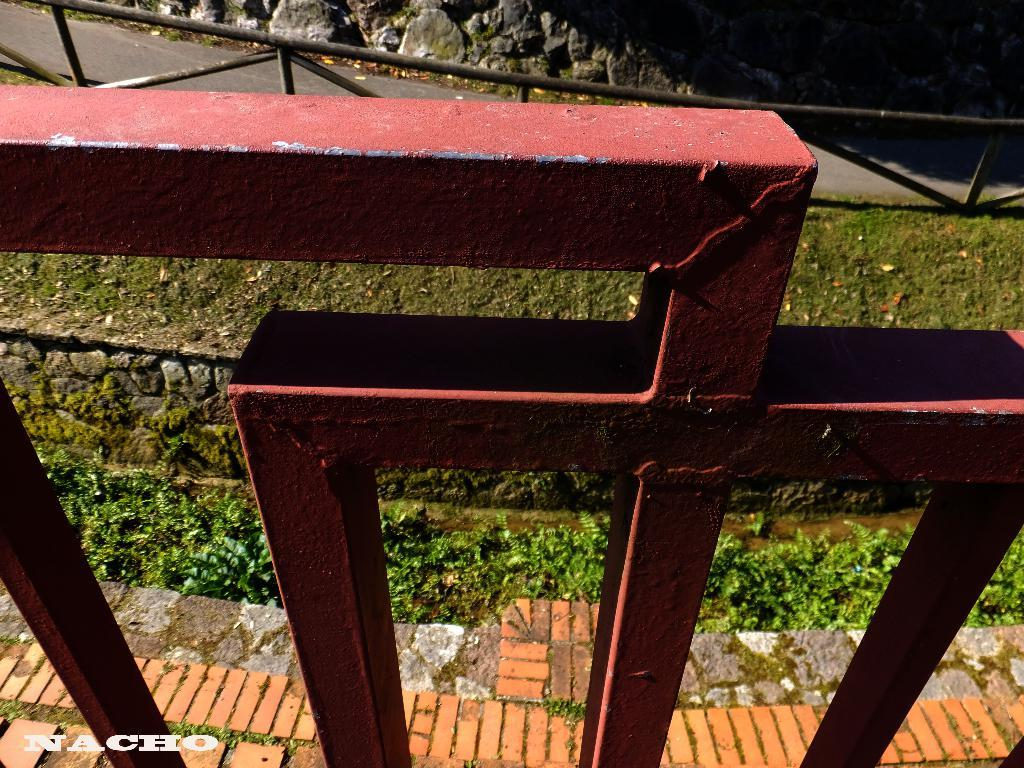What type of barrier is present in the image? There is an iron fence in the image. What surface can be seen beneath the plants? There is a floor visible in the image. What type of vegetation is near the floor? There are plants beside the floor. What is the background of the image made of? There is a wall in the image. What material is present on the ground? Stones are present in the image. What is the cause of the argument between the snow and the plants in the image? There is no argument between the snow and the plants in the image, as there is no snow present. What type of can is visible in the image? There is no can present in the image. 